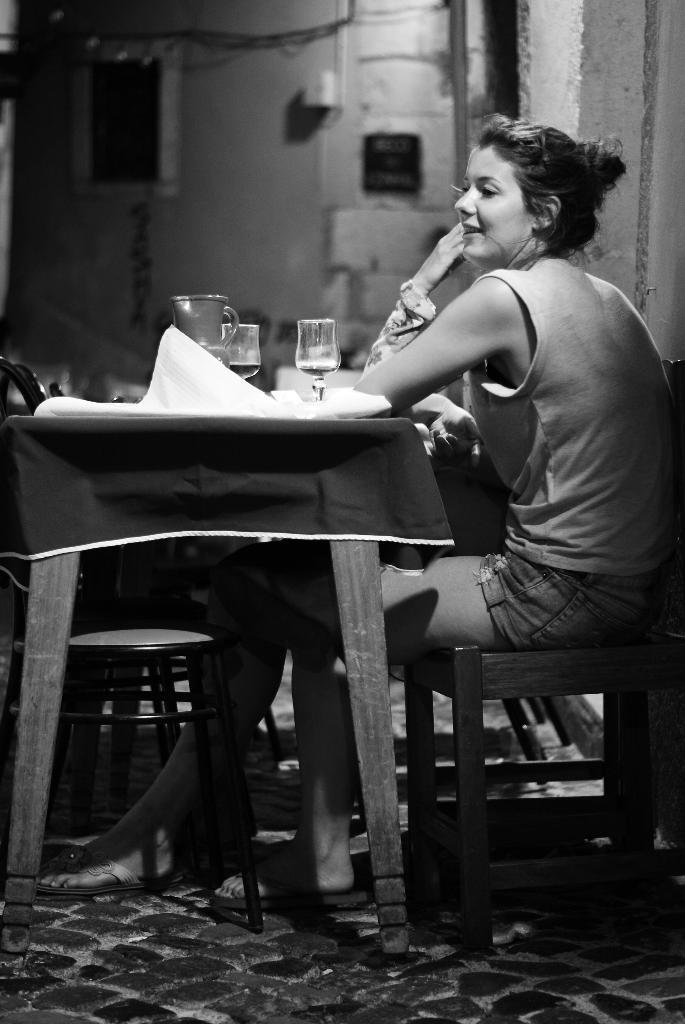Who is the main subject in the image? There is a lady in the image. What is the lady doing in the image? The lady is sitting on a stool. Where is the stool located in relation to the table? The stool is in front of a table. What items can be seen on the table? There are glasses and jars on the table. Are there any seating options near the table? Yes, there are chairs near the table. What color is the pig's stocking in the image? There is no pig or stocking present in the image. How many screws are visible on the table in the image? There are no screws visible on the table in the image. 